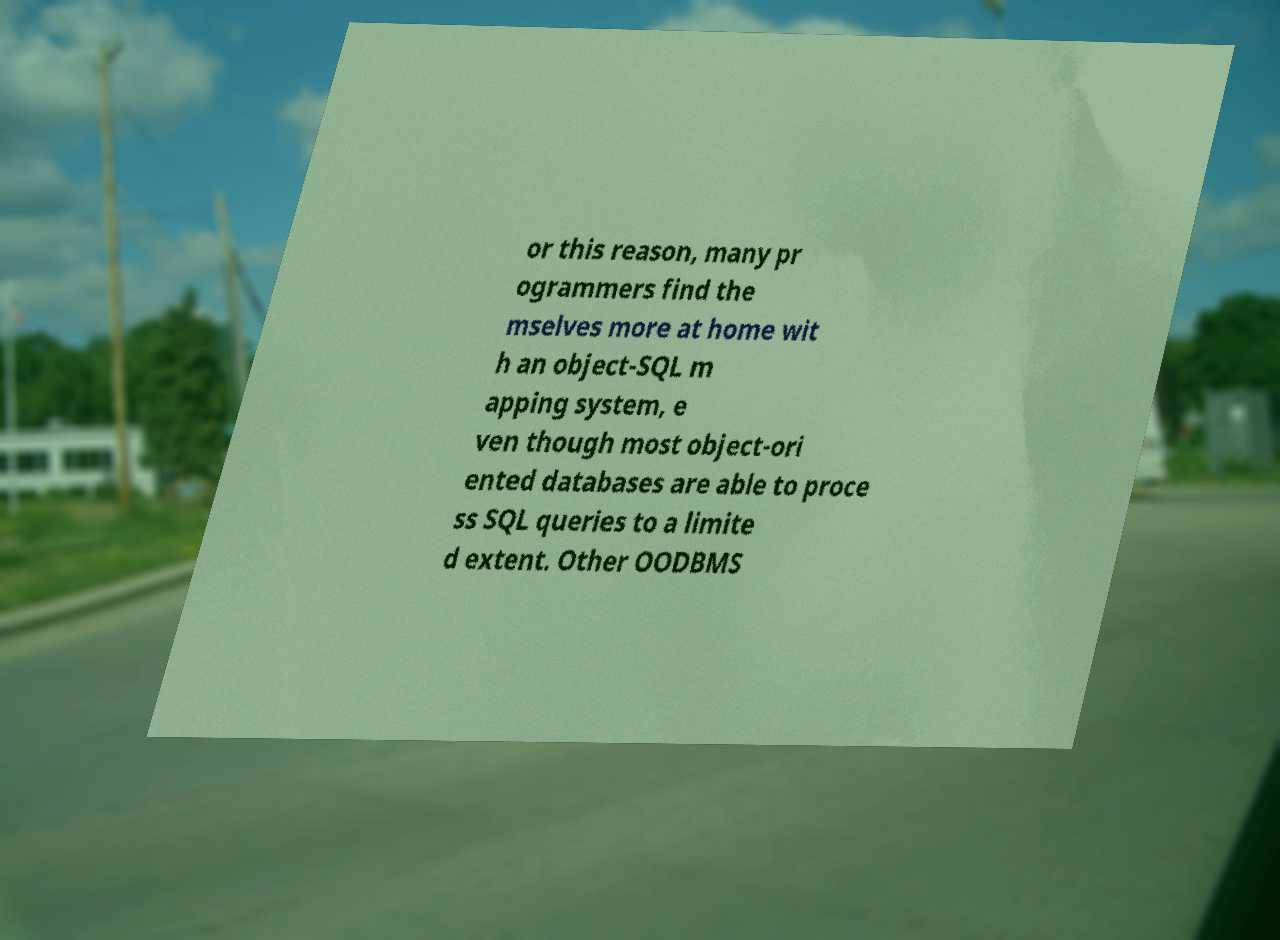I need the written content from this picture converted into text. Can you do that? or this reason, many pr ogrammers find the mselves more at home wit h an object-SQL m apping system, e ven though most object-ori ented databases are able to proce ss SQL queries to a limite d extent. Other OODBMS 